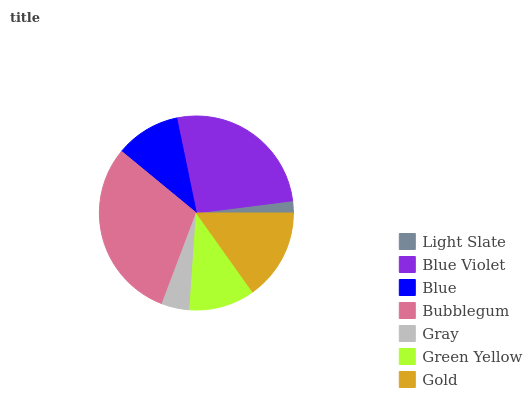Is Light Slate the minimum?
Answer yes or no. Yes. Is Bubblegum the maximum?
Answer yes or no. Yes. Is Blue Violet the minimum?
Answer yes or no. No. Is Blue Violet the maximum?
Answer yes or no. No. Is Blue Violet greater than Light Slate?
Answer yes or no. Yes. Is Light Slate less than Blue Violet?
Answer yes or no. Yes. Is Light Slate greater than Blue Violet?
Answer yes or no. No. Is Blue Violet less than Light Slate?
Answer yes or no. No. Is Green Yellow the high median?
Answer yes or no. Yes. Is Green Yellow the low median?
Answer yes or no. Yes. Is Light Slate the high median?
Answer yes or no. No. Is Bubblegum the low median?
Answer yes or no. No. 